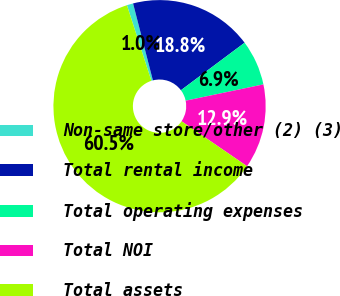Convert chart to OTSL. <chart><loc_0><loc_0><loc_500><loc_500><pie_chart><fcel>Non-same store/other (2) (3)<fcel>Total rental income<fcel>Total operating expenses<fcel>Total NOI<fcel>Total assets<nl><fcel>0.96%<fcel>18.81%<fcel>6.91%<fcel>12.86%<fcel>60.45%<nl></chart> 